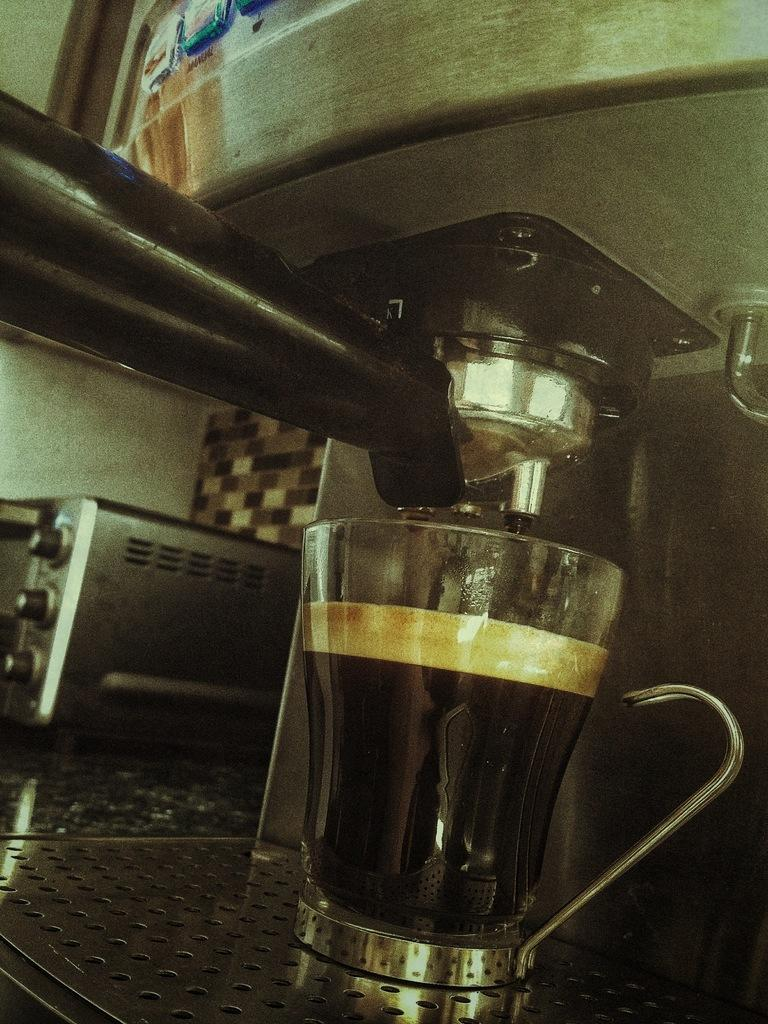What appliance is the main subject of the image? There is a coffee machine in the image. What is the coffee machine's purpose? The coffee machine is used for making coffee. What can be seen beside the coffee machine? There is a coffee cup with coffee in it and an oven beside the coffee machine. What is the background of the image? There is a wall in the background of the image. How does the rice compare to the coffee machine in the image? There is no rice present in the image, so it cannot be compared to the coffee machine. 